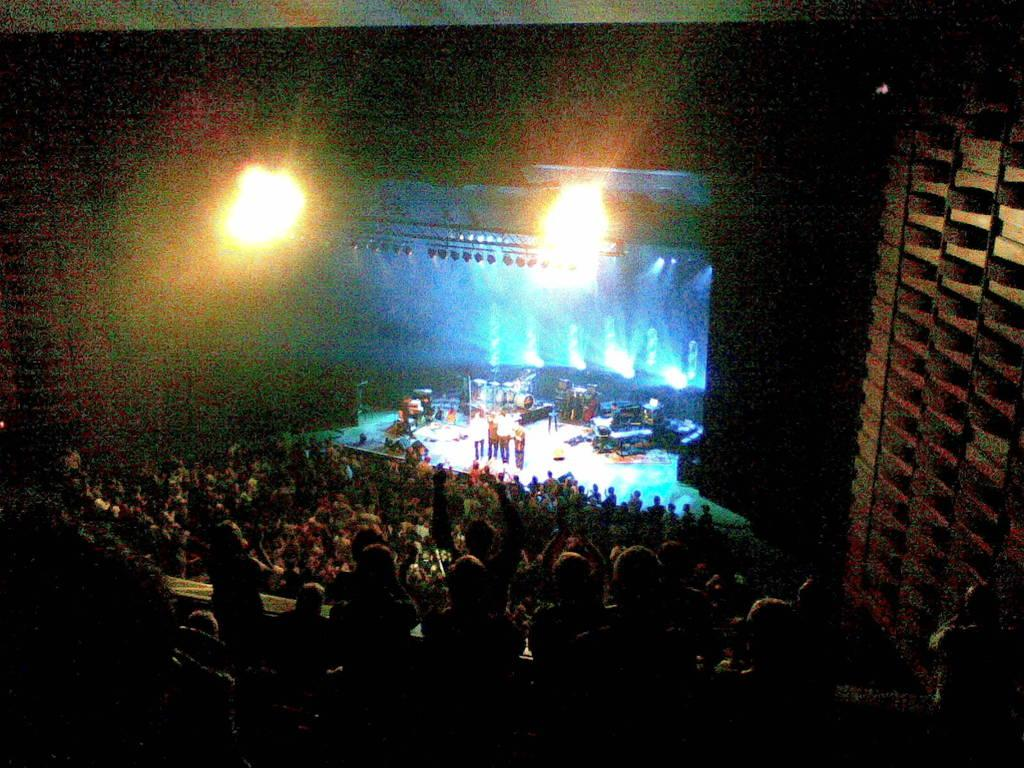How many people are present in the image? There are many people in the image. What are the people wearing? The people are wearing clothes. Where are some of the people located in the image? There are people on a stage. What can be seen in the image that provides illumination? There are lights visible in the image. How would you describe the lighting conditions in the corners of the image? The corners of the image are dark. Reasoning: Let's think step by breaking down the conversation step by step. We start by acknowledging the presence of many people in the image. Then, we describe what the people are wearing, which is clothes. Next, we identify the location of some people, who are on a stage. We mention the presence of lights in the image, which provide illumination. Finally, we describe the lighting conditions in the corners of the image, which are dark. Absurd Question/Answer: What type of egg is being used as a prop on the stage in the image? There is no egg present in the image, let alone being used as a prop on the stage. 